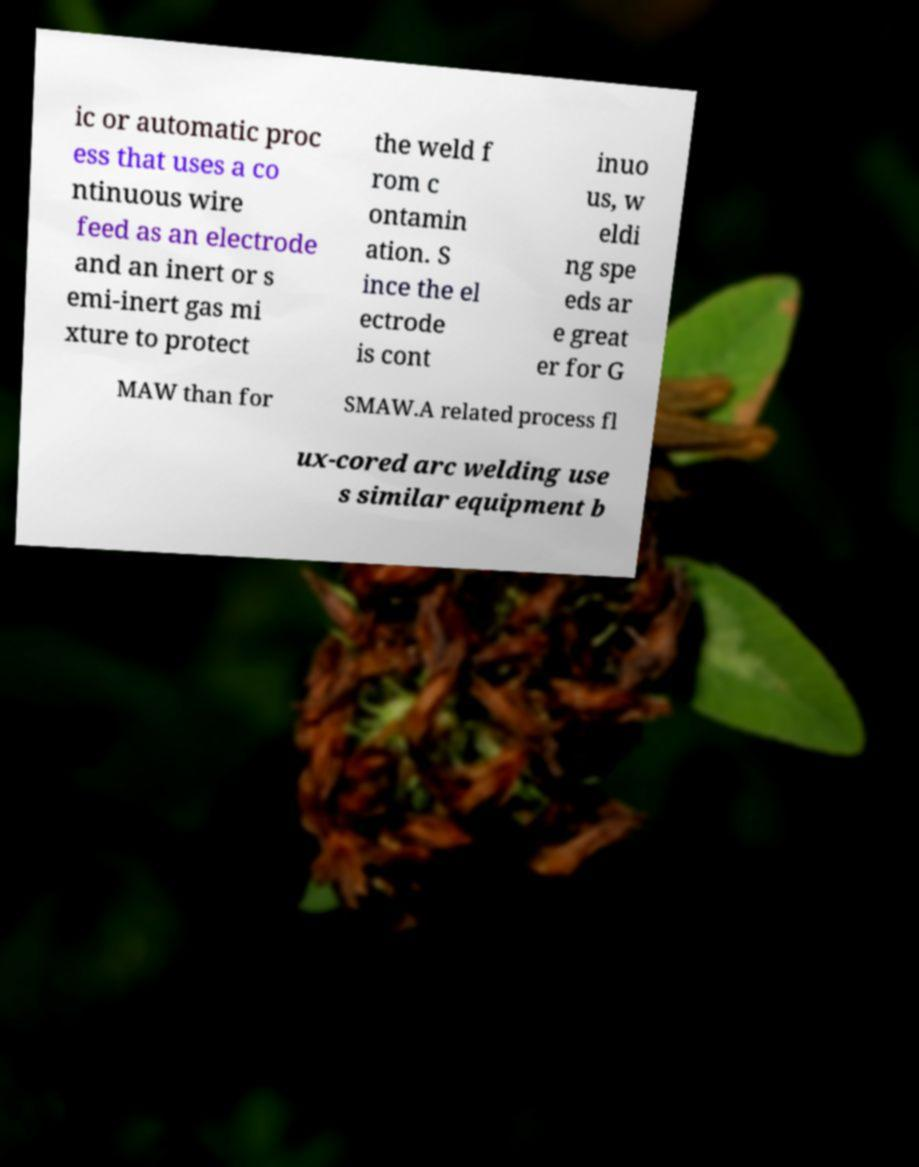There's text embedded in this image that I need extracted. Can you transcribe it verbatim? ic or automatic proc ess that uses a co ntinuous wire feed as an electrode and an inert or s emi-inert gas mi xture to protect the weld f rom c ontamin ation. S ince the el ectrode is cont inuo us, w eldi ng spe eds ar e great er for G MAW than for SMAW.A related process fl ux-cored arc welding use s similar equipment b 